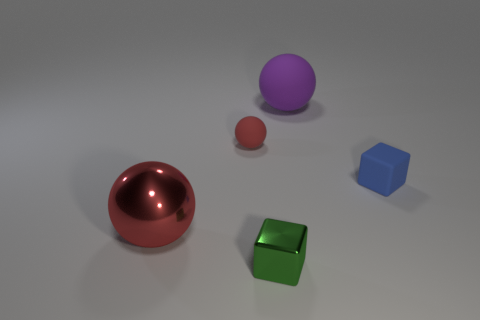Add 2 blue blocks. How many objects exist? 7 Subtract 1 cubes. How many cubes are left? 1 Subtract all blue cubes. How many cubes are left? 1 Subtract all red balls. How many balls are left? 1 Subtract all balls. How many objects are left? 2 Subtract all brown metallic blocks. Subtract all red metallic spheres. How many objects are left? 4 Add 3 big matte things. How many big matte things are left? 4 Add 2 large purple objects. How many large purple objects exist? 3 Subtract 0 gray cylinders. How many objects are left? 5 Subtract all yellow blocks. Subtract all yellow spheres. How many blocks are left? 2 